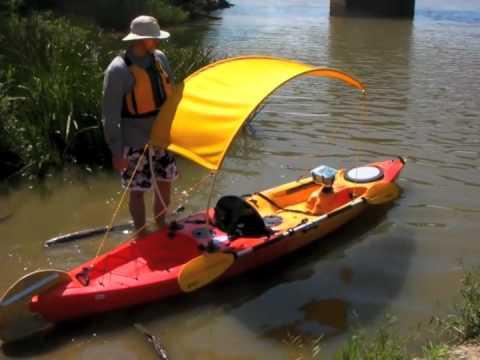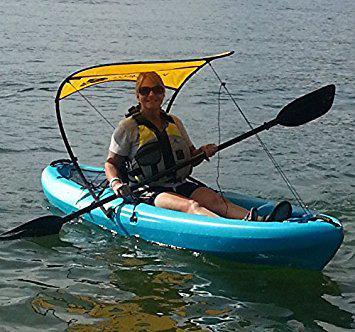The first image is the image on the left, the second image is the image on the right. Assess this claim about the two images: "There is a person in a canoe, on the water, facing right.". Correct or not? Answer yes or no. Yes. The first image is the image on the left, the second image is the image on the right. Considering the images on both sides, is "There is a red canoe in water in the left image." valid? Answer yes or no. Yes. 